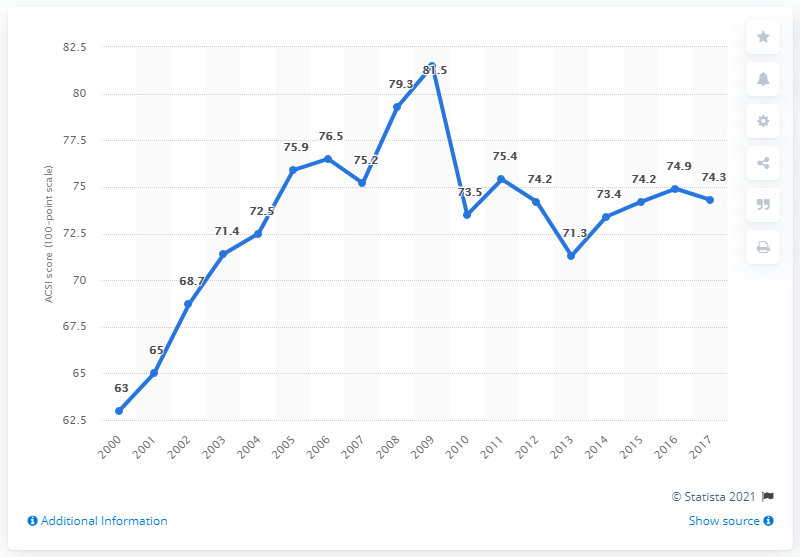Highlight a few significant elements in this photo. In 2017, the score for customer satisfaction with e-business was 74.3%. 